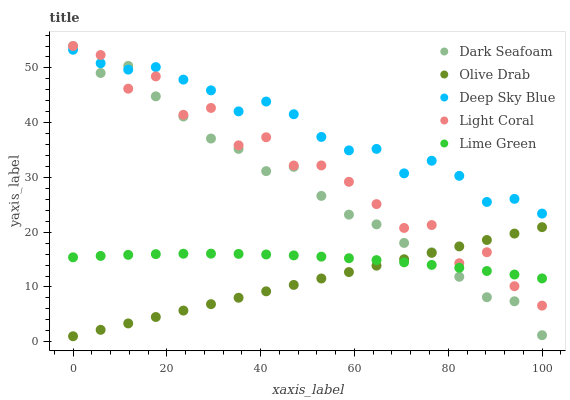Does Olive Drab have the minimum area under the curve?
Answer yes or no. Yes. Does Deep Sky Blue have the maximum area under the curve?
Answer yes or no. Yes. Does Dark Seafoam have the minimum area under the curve?
Answer yes or no. No. Does Dark Seafoam have the maximum area under the curve?
Answer yes or no. No. Is Olive Drab the smoothest?
Answer yes or no. Yes. Is Light Coral the roughest?
Answer yes or no. Yes. Is Dark Seafoam the smoothest?
Answer yes or no. No. Is Dark Seafoam the roughest?
Answer yes or no. No. Does Olive Drab have the lowest value?
Answer yes or no. Yes. Does Dark Seafoam have the lowest value?
Answer yes or no. No. Does Dark Seafoam have the highest value?
Answer yes or no. Yes. Does Lime Green have the highest value?
Answer yes or no. No. Is Lime Green less than Deep Sky Blue?
Answer yes or no. Yes. Is Deep Sky Blue greater than Olive Drab?
Answer yes or no. Yes. Does Deep Sky Blue intersect Light Coral?
Answer yes or no. Yes. Is Deep Sky Blue less than Light Coral?
Answer yes or no. No. Is Deep Sky Blue greater than Light Coral?
Answer yes or no. No. Does Lime Green intersect Deep Sky Blue?
Answer yes or no. No. 